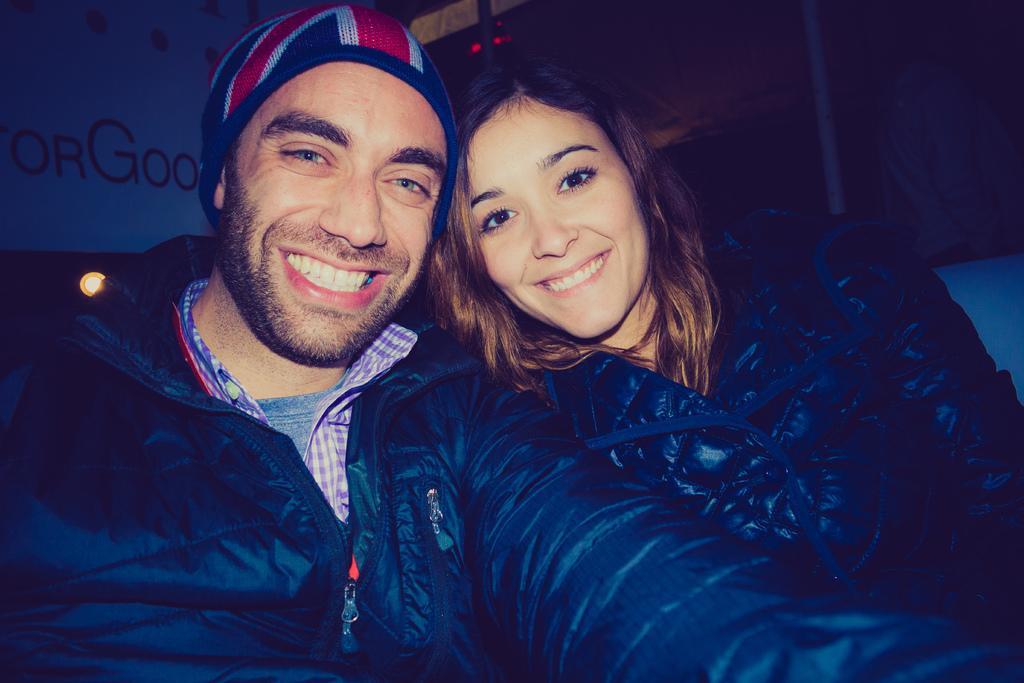How would you summarize this image in a sentence or two? There are two persons wearing a black color jackets and they are smiling. There is a wall poster as we can see at the top left side of this image. 